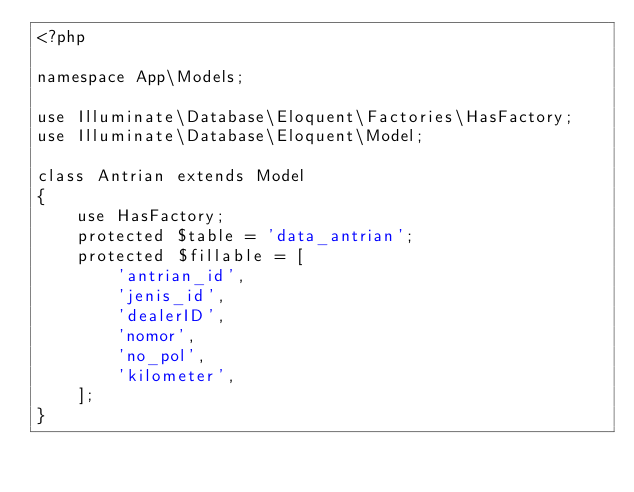<code> <loc_0><loc_0><loc_500><loc_500><_PHP_><?php

namespace App\Models;

use Illuminate\Database\Eloquent\Factories\HasFactory;
use Illuminate\Database\Eloquent\Model;

class Antrian extends Model
{
    use HasFactory;
    protected $table = 'data_antrian';
    protected $fillable = [
        'antrian_id',
        'jenis_id',
        'dealerID',
        'nomor',
        'no_pol',
        'kilometer',
    ];
}
</code> 